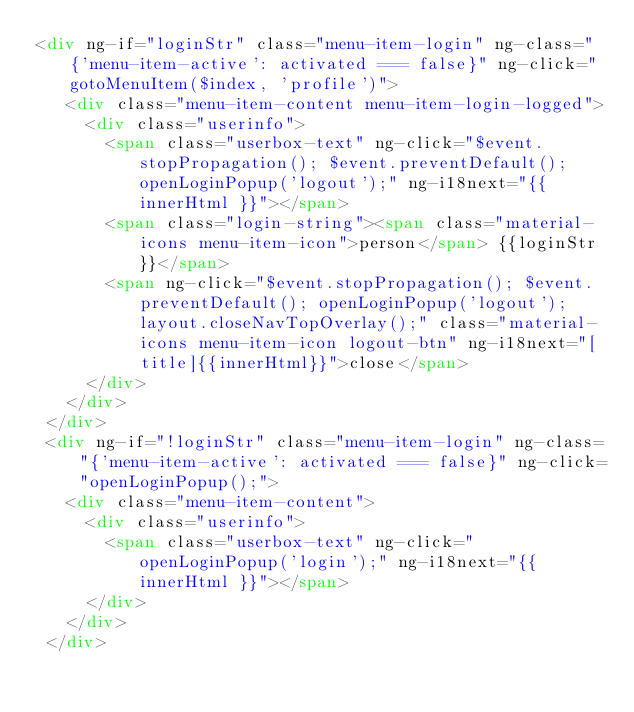Convert code to text. <code><loc_0><loc_0><loc_500><loc_500><_HTML_><div ng-if="loginStr" class="menu-item-login" ng-class="{'menu-item-active': activated === false}" ng-click="gotoMenuItem($index, 'profile')">
   <div class="menu-item-content menu-item-login-logged">
     <div class="userinfo">
       <span class="userbox-text" ng-click="$event.stopPropagation(); $event.preventDefault(); openLoginPopup('logout');" ng-i18next="{{ innerHtml }}"></span>
       <span class="login-string"><span class="material-icons menu-item-icon">person</span> {{loginStr}}</span>
       <span ng-click="$event.stopPropagation(); $event.preventDefault(); openLoginPopup('logout'); layout.closeNavTopOverlay();" class="material-icons menu-item-icon logout-btn" ng-i18next="[title]{{innerHtml}}">close</span>
     </div>
   </div>
 </div>
 <div ng-if="!loginStr" class="menu-item-login" ng-class="{'menu-item-active': activated === false}" ng-click="openLoginPopup();">
   <div class="menu-item-content">
     <div class="userinfo">
       <span class="userbox-text" ng-click="openLoginPopup('login');" ng-i18next="{{ innerHtml }}"></span>
     </div>
   </div>
 </div>
</code> 